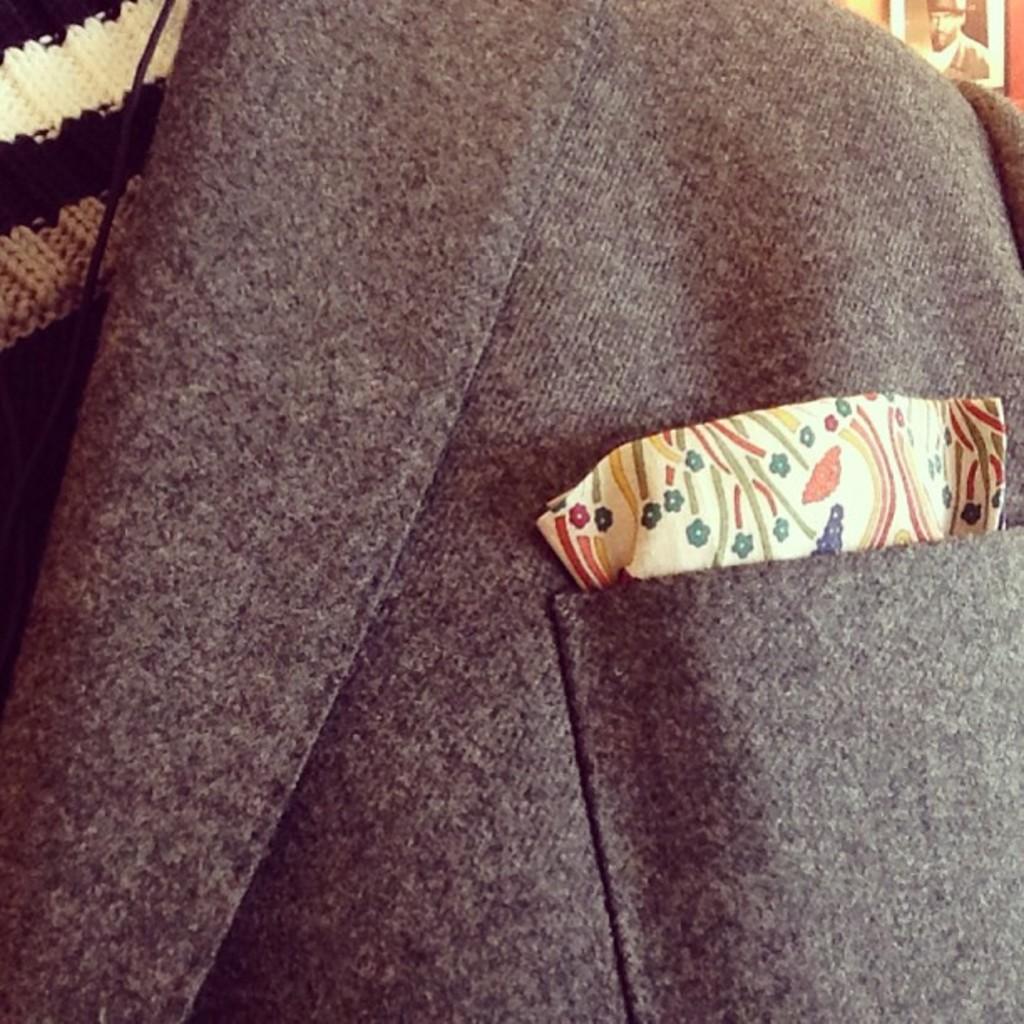How would you summarize this image in a sentence or two? The picture consists of a jacket. On the right we can see a photograph. On the left there is a cloth. 